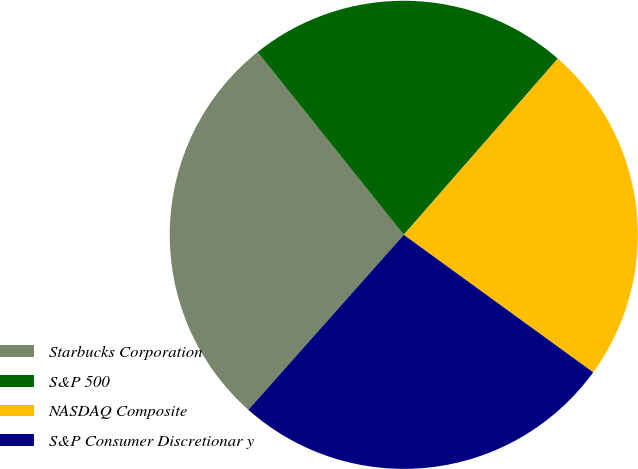<chart> <loc_0><loc_0><loc_500><loc_500><pie_chart><fcel>Starbucks Corporation<fcel>S&P 500<fcel>NASDAQ Composite<fcel>S&P Consumer Discretionar y<nl><fcel>27.7%<fcel>22.18%<fcel>23.56%<fcel>26.57%<nl></chart> 